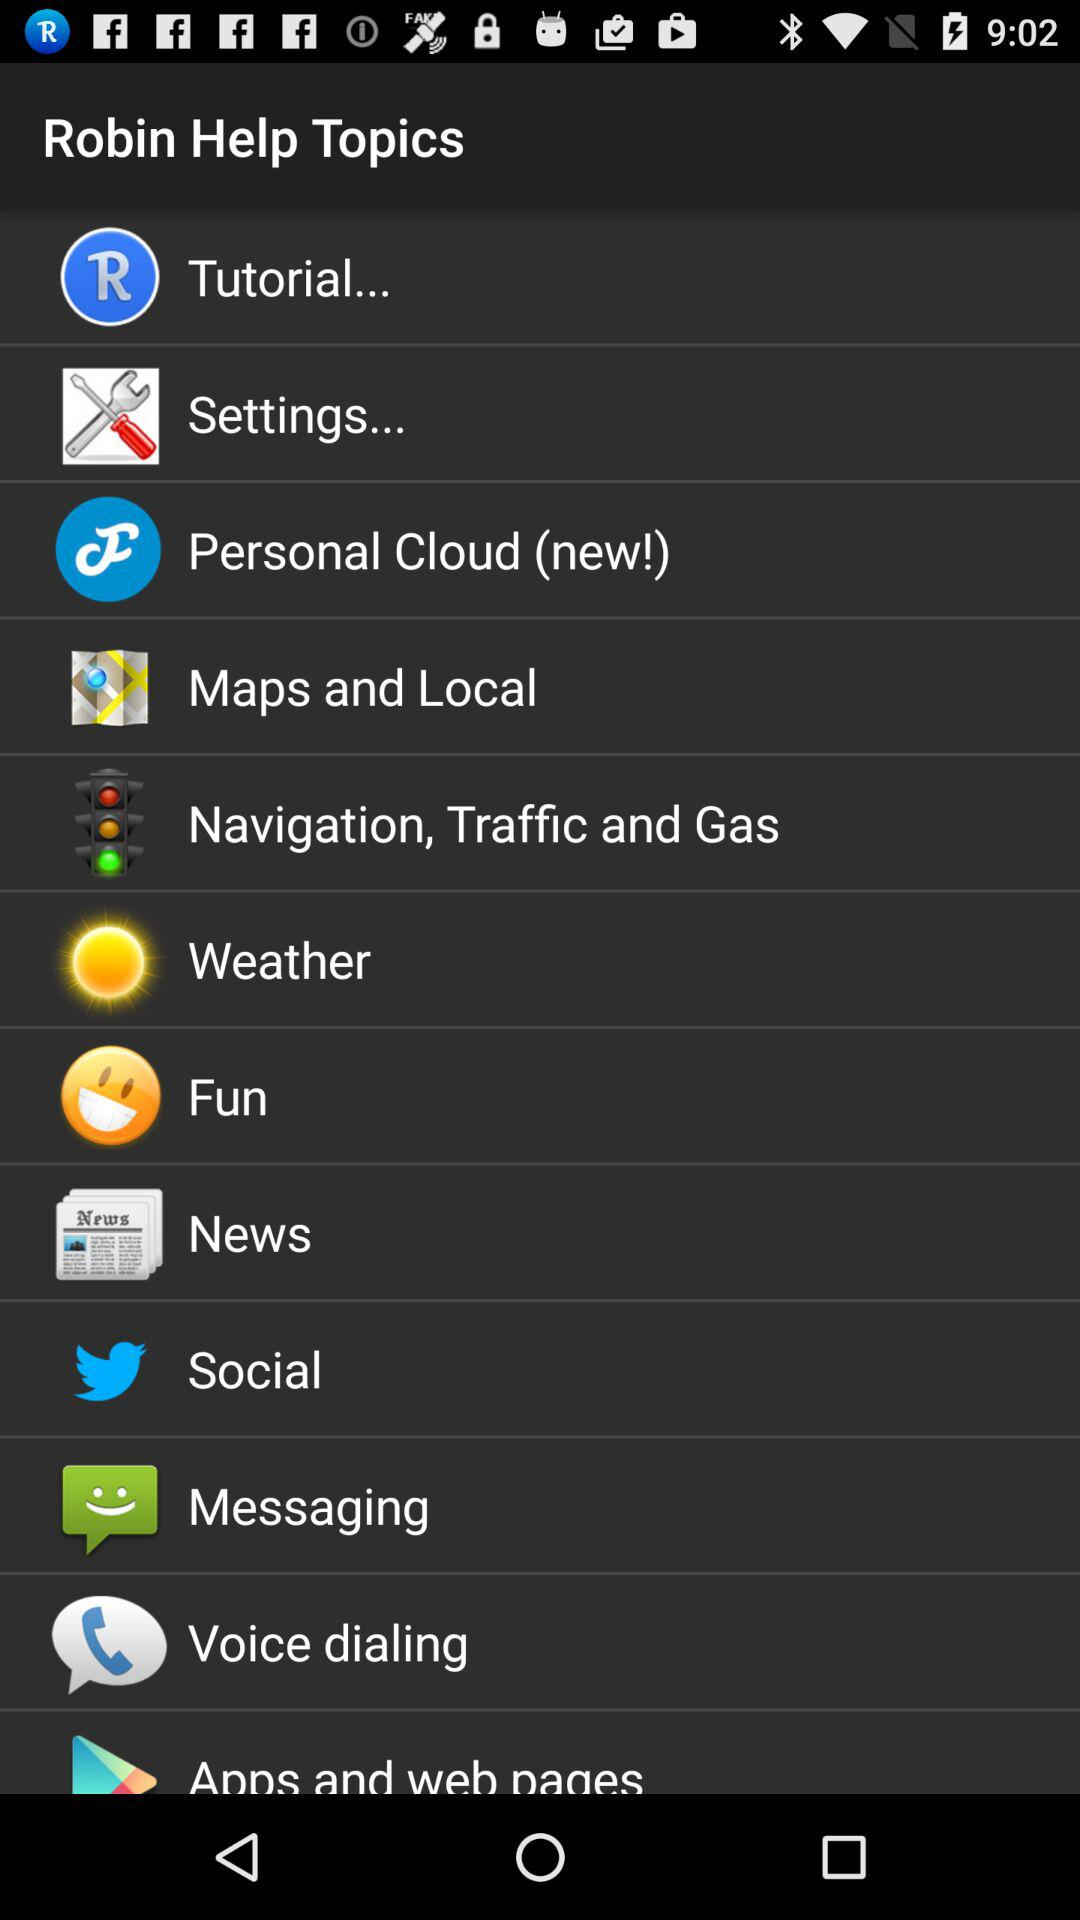What is the application Name? The application name is Robin. 